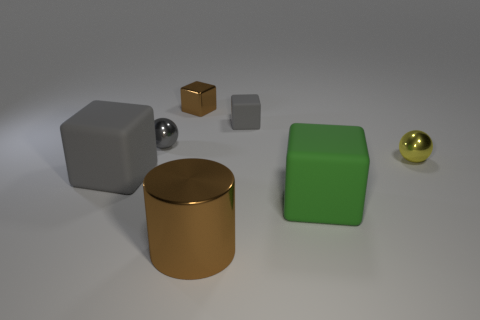There is a ball to the left of the brown thing behind the brown thing in front of the brown metallic cube; what is its size?
Provide a succinct answer. Small. Do the metallic cylinder and the green matte thing have the same size?
Your answer should be very brief. Yes. There is a small object in front of the tiny gray shiny ball to the left of the brown metal cube; what is it made of?
Your answer should be very brief. Metal. There is a large object that is to the left of the big brown metallic thing; does it have the same shape as the metallic object that is in front of the large green block?
Your answer should be very brief. No. Is the number of large gray matte objects behind the tiny brown metal object the same as the number of small matte objects?
Offer a terse response. No. Are there any tiny gray metallic objects that are right of the big matte thing that is on the right side of the brown metal cylinder?
Offer a terse response. No. Is there anything else that is the same color as the tiny metallic cube?
Provide a short and direct response. Yes. Are the sphere that is on the right side of the big metallic cylinder and the brown cylinder made of the same material?
Offer a very short reply. Yes. Are there the same number of large green rubber objects that are to the right of the small gray sphere and big gray rubber objects that are behind the tiny yellow object?
Ensure brevity in your answer.  No. There is a brown thing on the left side of the big brown cylinder right of the gray metallic ball; how big is it?
Your answer should be compact. Small. 